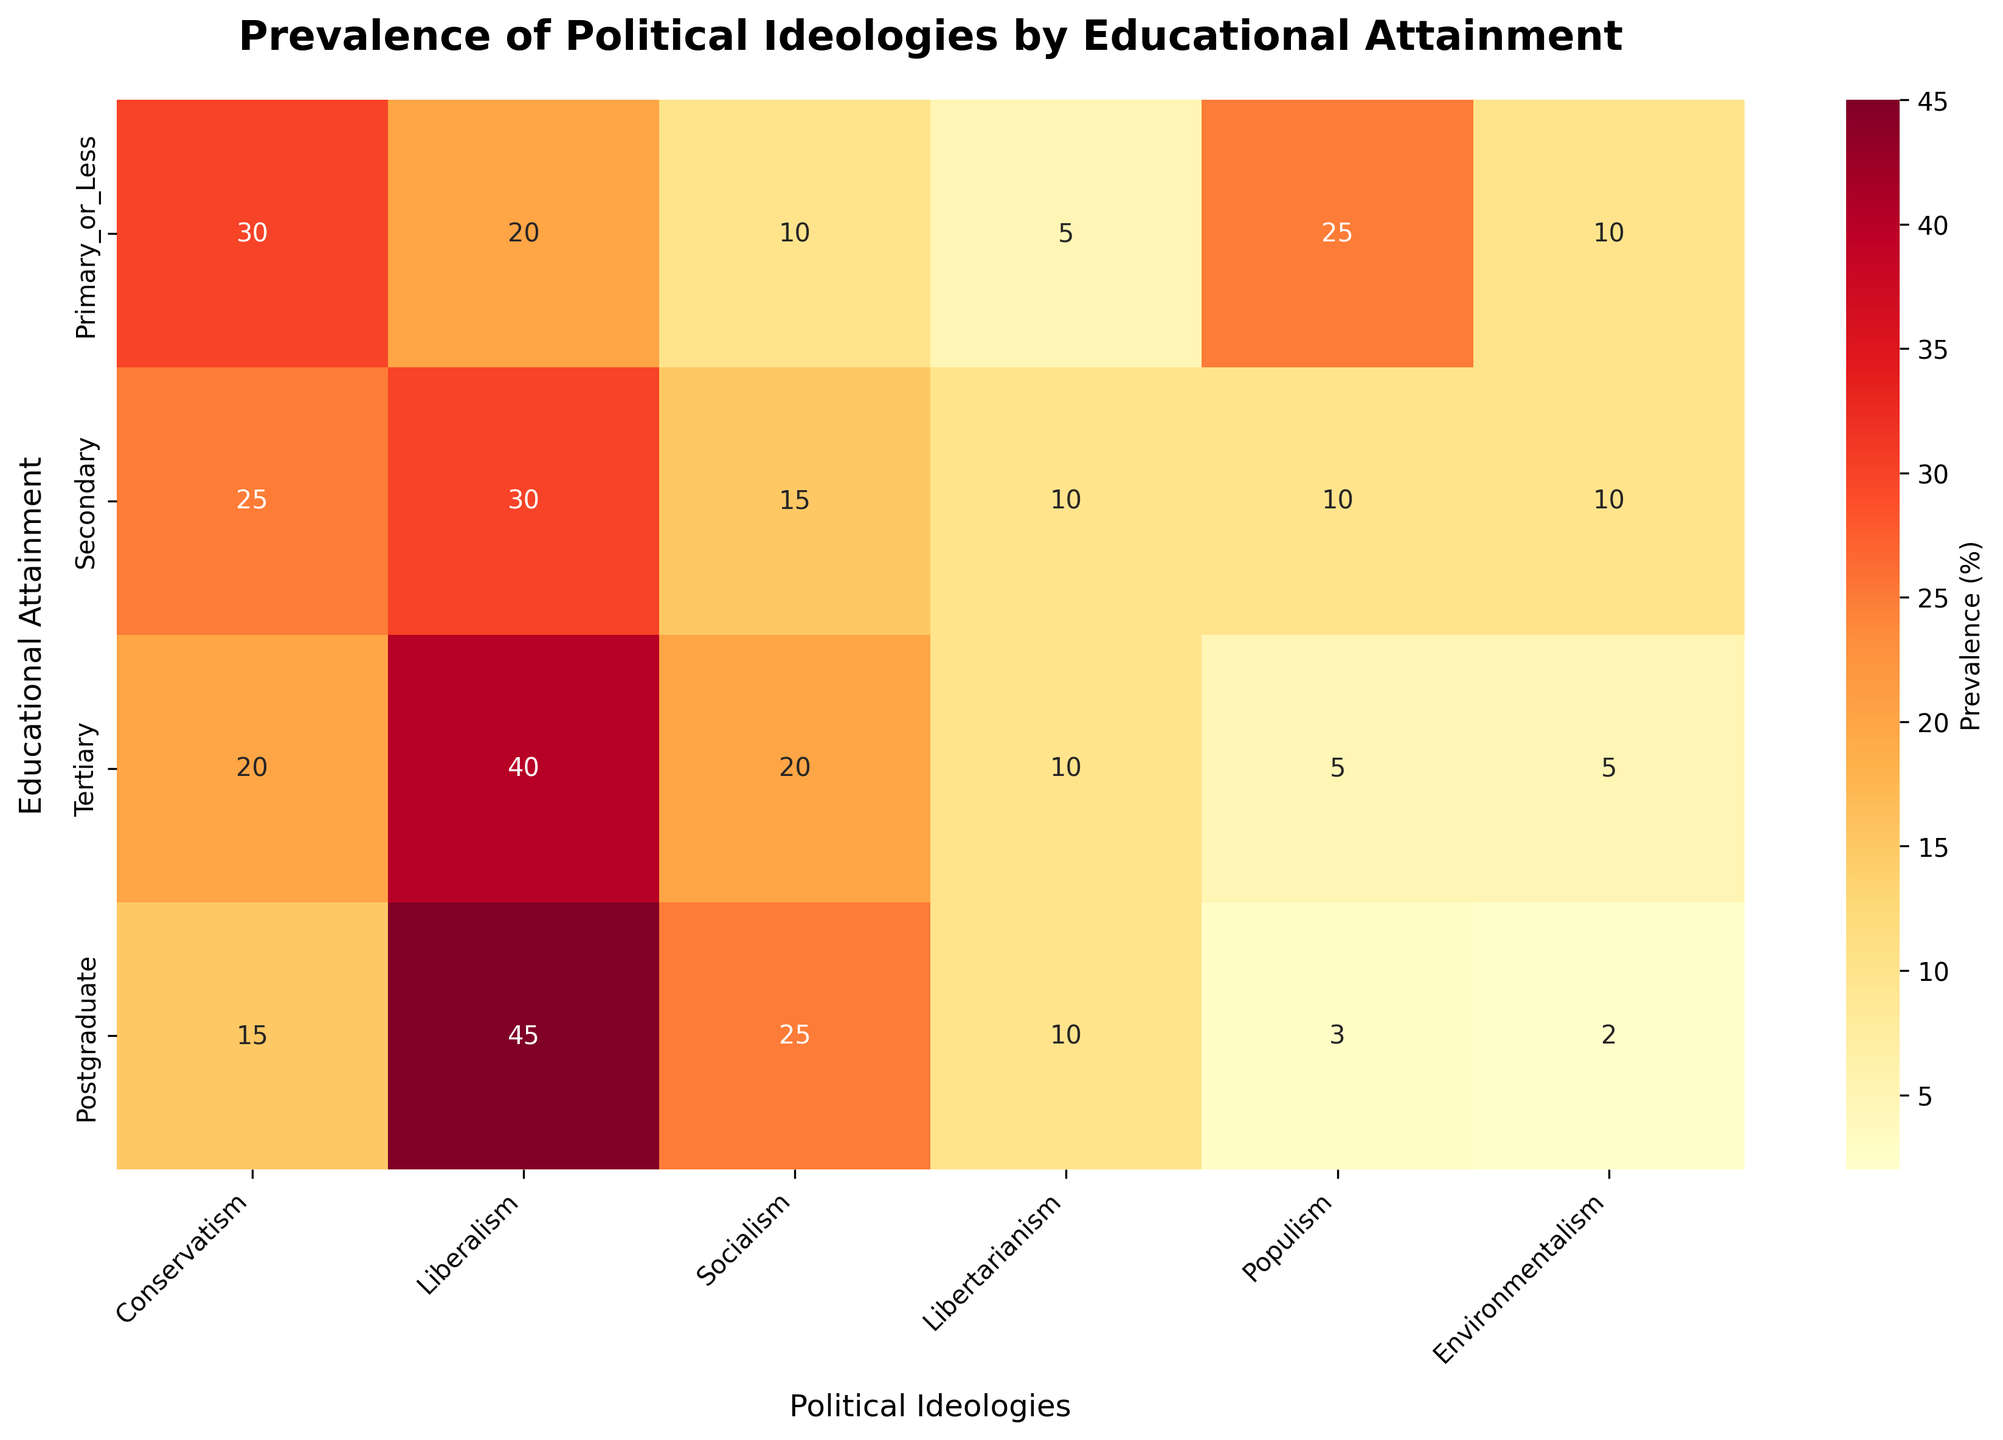What educational attainment level has the highest prevalence of Liberalism? Visual inspection reveals that the row for "Postgraduate" has the highest value in the "Liberalism" column.
Answer: Postgraduate Which political ideology shows a decreasing trend as educational attainment increases? By examining each column, "Conservatism" shows a decreasing trend from 30% at Primary_or_Less to 15% at Postgraduate.
Answer: Conservatism What is the total prevalence of Populism for Primary or Less and Secondary educational attainment levels? The Populism prevalence is 25% for Primary or Less and 10% for Secondary. The sum is 25 + 10 = 35.
Answer: 35 Which two educational levels have the same prevalence for Environmentalism and what is the value? Both "Primary_or_Less" and "Secondary" rows show 10% prevalence in the "Environmentalism" column.
Answer: Primary_or_Less and Secondary, 10 What educational attainment level has the lowest prevalence of Libertarianism? Visual inspection indicates that all rows have 10% prevalence for Libertarianism except "Primary_or_Less" which has 5%. Thus, "Primary_or_Less" is the lowest.
Answer: Primary_or_Less Does the prevalence of Socialism increase or decrease with educational attainment? Observing the Socialism column, prevalence increases from 10% in Primary or Less to 25% in Postgraduate.
Answer: Increase Which ideology has the highest prevalence in "Secondary" education level? Looking at the "Secondary" row, the highest value is 30%, which corresponds to Liberalism.
Answer: Liberalism How does the prevalence of Environmentalism compare across different educational attainment levels? It starts at 10% for Primary or Less, remains 10% for Secondary, then drops to 5% for Tertiary, and 2% for Postgraduate.
Answer: It generally decreases with higher educational attainment What is the difference in prevalence of Socialism between "Primary_or_Less" and "Postgraduate"? "Postgraduate" has 25% and "Primary_or_Less" has 10%, so the difference is 25 - 10 = 15.
Answer: 15 Which ideology has an equally distributed prevalence across the educational levels? Conservatism has a prevalence of 30%, 25%, 20%, and 15% respectively; none of the ideologies have an equal distribution.
Answer: None 